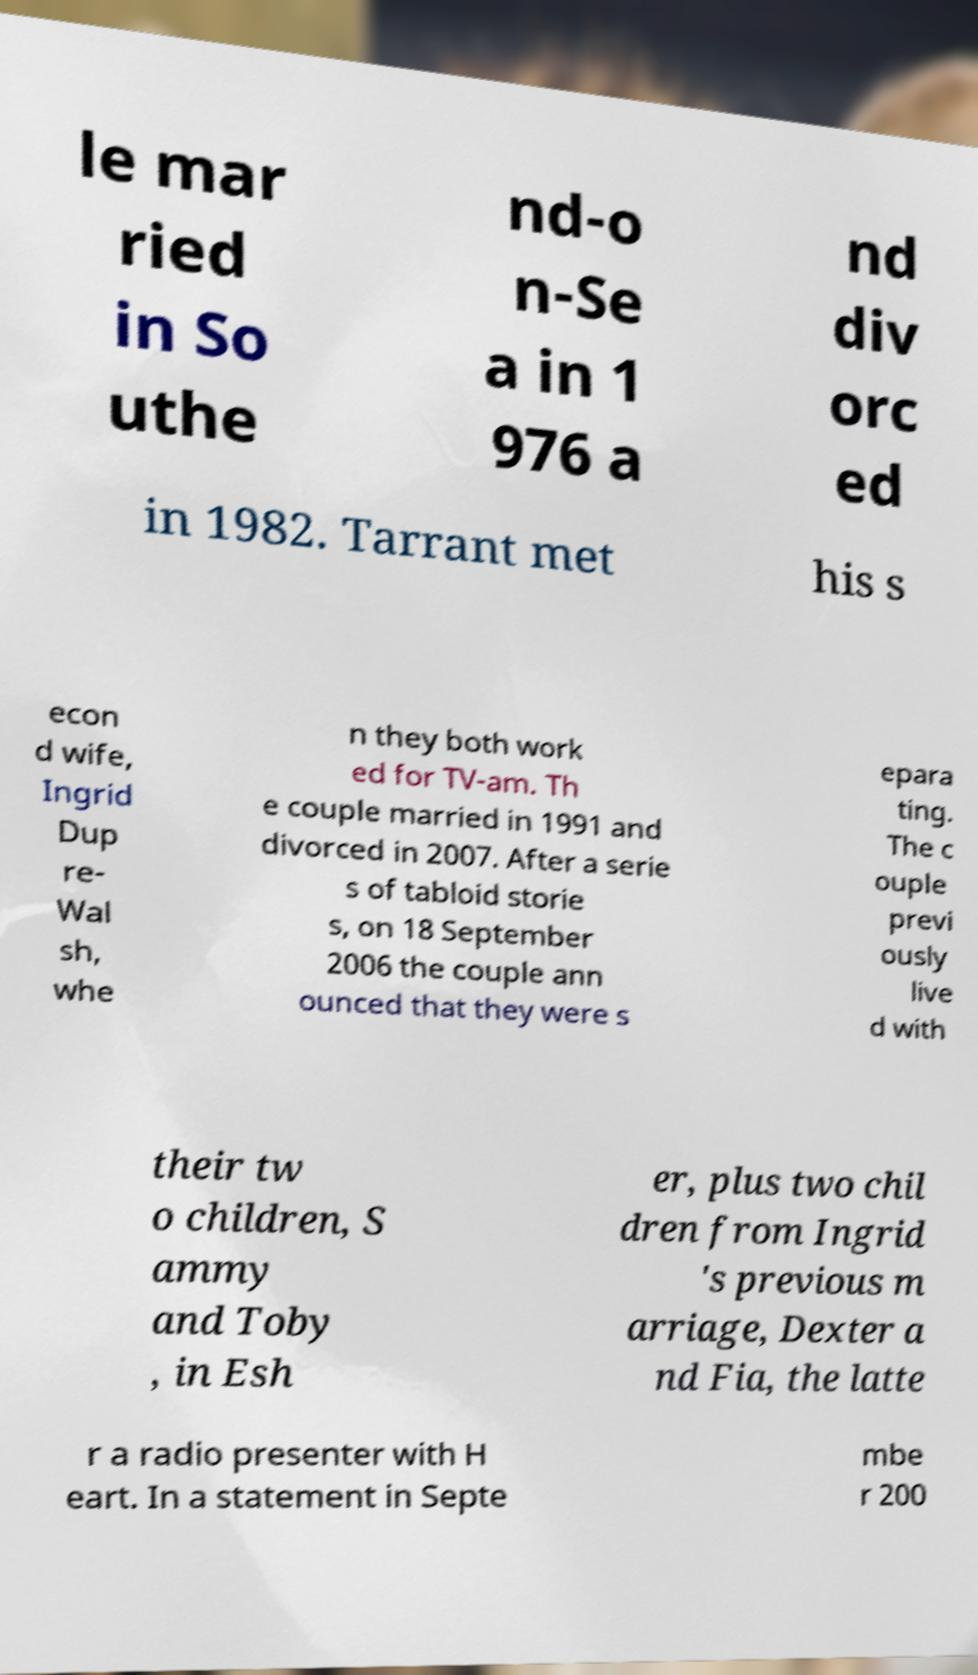Could you assist in decoding the text presented in this image and type it out clearly? le mar ried in So uthe nd-o n-Se a in 1 976 a nd div orc ed in 1982. Tarrant met his s econ d wife, Ingrid Dup re- Wal sh, whe n they both work ed for TV-am. Th e couple married in 1991 and divorced in 2007. After a serie s of tabloid storie s, on 18 September 2006 the couple ann ounced that they were s epara ting. The c ouple previ ously live d with their tw o children, S ammy and Toby , in Esh er, plus two chil dren from Ingrid 's previous m arriage, Dexter a nd Fia, the latte r a radio presenter with H eart. In a statement in Septe mbe r 200 